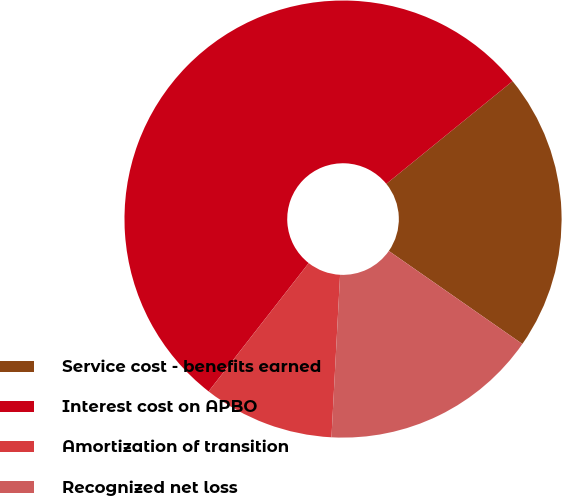Convert chart to OTSL. <chart><loc_0><loc_0><loc_500><loc_500><pie_chart><fcel>Service cost - benefits earned<fcel>Interest cost on APBO<fcel>Amortization of transition<fcel>Recognized net loss<nl><fcel>20.55%<fcel>53.59%<fcel>9.7%<fcel>16.16%<nl></chart> 